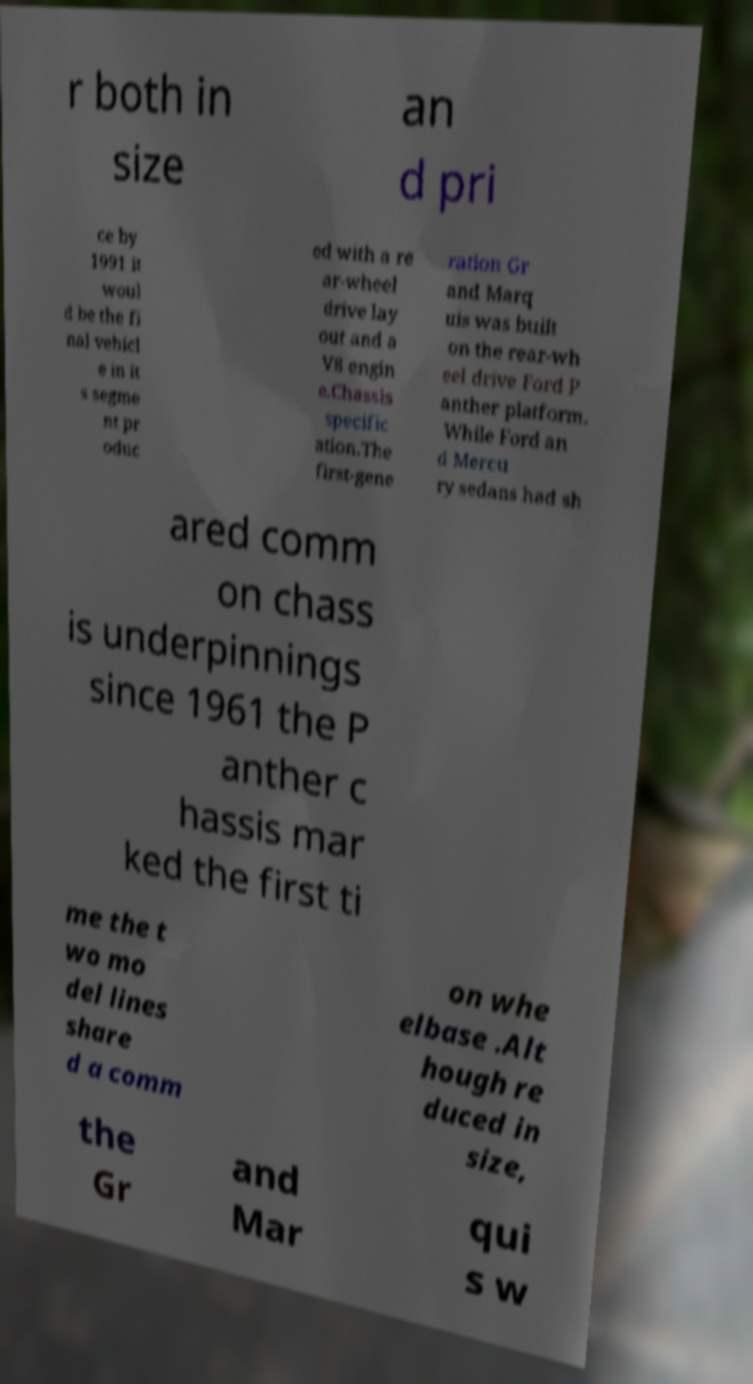Can you read and provide the text displayed in the image?This photo seems to have some interesting text. Can you extract and type it out for me? r both in size an d pri ce by 1991 it woul d be the fi nal vehicl e in it s segme nt pr oduc ed with a re ar-wheel drive lay out and a V8 engin e.Chassis specific ation.The first-gene ration Gr and Marq uis was built on the rear-wh eel drive Ford P anther platform. While Ford an d Mercu ry sedans had sh ared comm on chass is underpinnings since 1961 the P anther c hassis mar ked the first ti me the t wo mo del lines share d a comm on whe elbase .Alt hough re duced in size, the Gr and Mar qui s w 